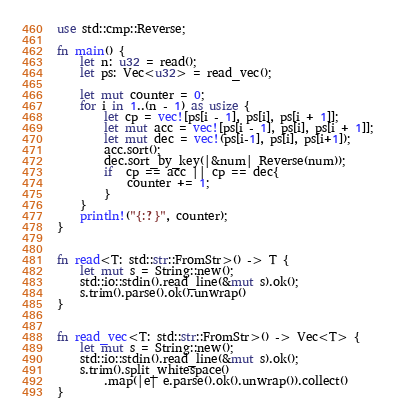<code> <loc_0><loc_0><loc_500><loc_500><_Rust_>use std::cmp::Reverse;

fn main() {
    let n: u32 = read();
    let ps: Vec<u32> = read_vec();

    let mut counter = 0;
    for i in 1..(n - 1) as usize {
        let cp = vec![ps[i - 1], ps[i], ps[i + 1]];
        let mut acc = vec![ps[i - 1], ps[i], ps[i + 1]];
        let mut dec = vec!(ps[i-1], ps[i], ps[i+1]);
        acc.sort();
        dec.sort_by_key(|&num| Reverse(num));
        if  cp == acc || cp == dec{
            counter += 1;
        }
    }
    println!("{:?}", counter);
}


fn read<T: std::str::FromStr>() -> T {
    let mut s = String::new();
    std::io::stdin().read_line(&mut s).ok();
    s.trim().parse().ok().unwrap()
}


fn read_vec<T: std::str::FromStr>() -> Vec<T> {
    let mut s = String::new();
    std::io::stdin().read_line(&mut s).ok();
    s.trim().split_whitespace()
        .map(|e| e.parse().ok().unwrap()).collect()
}
</code> 